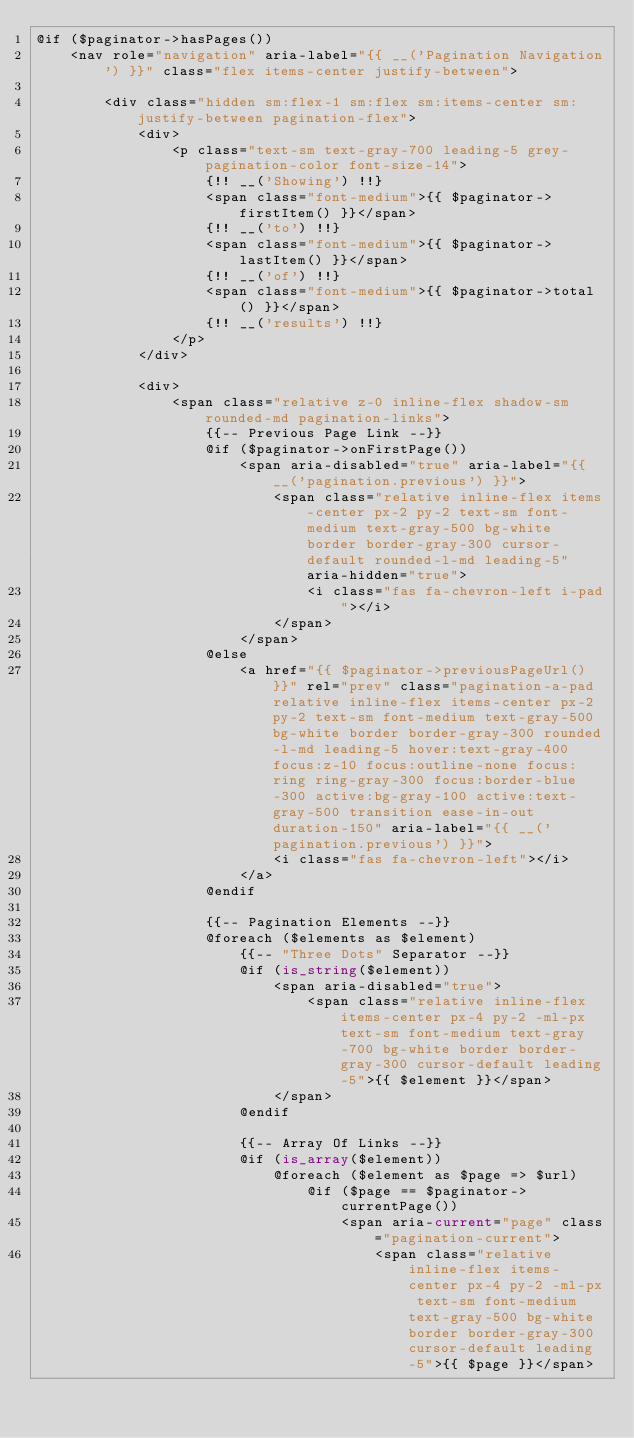<code> <loc_0><loc_0><loc_500><loc_500><_PHP_>@if ($paginator->hasPages())
    <nav role="navigation" aria-label="{{ __('Pagination Navigation') }}" class="flex items-center justify-between">

        <div class="hidden sm:flex-1 sm:flex sm:items-center sm:justify-between pagination-flex">
            <div>
                <p class="text-sm text-gray-700 leading-5 grey-pagination-color font-size-14">
                    {!! __('Showing') !!}
                    <span class="font-medium">{{ $paginator->firstItem() }}</span>
                    {!! __('to') !!}
                    <span class="font-medium">{{ $paginator->lastItem() }}</span>
                    {!! __('of') !!}
                    <span class="font-medium">{{ $paginator->total() }}</span>
                    {!! __('results') !!}
                </p>
            </div>

            <div>
                <span class="relative z-0 inline-flex shadow-sm rounded-md pagination-links">
                    {{-- Previous Page Link --}}
                    @if ($paginator->onFirstPage())
                        <span aria-disabled="true" aria-label="{{ __('pagination.previous') }}">
                            <span class="relative inline-flex items-center px-2 py-2 text-sm font-medium text-gray-500 bg-white border border-gray-300 cursor-default rounded-l-md leading-5" aria-hidden="true">
                                <i class="fas fa-chevron-left i-pad"></i>
                            </span>
                        </span>
                    @else
                        <a href="{{ $paginator->previousPageUrl() }}" rel="prev" class="pagination-a-pad relative inline-flex items-center px-2 py-2 text-sm font-medium text-gray-500 bg-white border border-gray-300 rounded-l-md leading-5 hover:text-gray-400 focus:z-10 focus:outline-none focus:ring ring-gray-300 focus:border-blue-300 active:bg-gray-100 active:text-gray-500 transition ease-in-out duration-150" aria-label="{{ __('pagination.previous') }}">
                            <i class="fas fa-chevron-left"></i>
                        </a>
                    @endif

                    {{-- Pagination Elements --}}
                    @foreach ($elements as $element)
                        {{-- "Three Dots" Separator --}}
                        @if (is_string($element))
                            <span aria-disabled="true">
                                <span class="relative inline-flex items-center px-4 py-2 -ml-px text-sm font-medium text-gray-700 bg-white border border-gray-300 cursor-default leading-5">{{ $element }}</span>
                            </span>
                        @endif

                        {{-- Array Of Links --}}
                        @if (is_array($element))
                            @foreach ($element as $page => $url)
                                @if ($page == $paginator->currentPage())
                                    <span aria-current="page" class="pagination-current">
                                        <span class="relative inline-flex items-center px-4 py-2 -ml-px text-sm font-medium text-gray-500 bg-white border border-gray-300 cursor-default leading-5">{{ $page }}</span></code> 